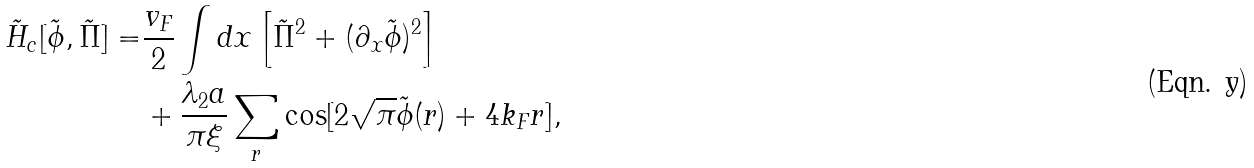Convert formula to latex. <formula><loc_0><loc_0><loc_500><loc_500>\tilde { H } _ { c } [ \tilde { \phi } , \tilde { \Pi } ] = & \frac { v _ { F } } { 2 } \int d x \left [ \tilde { \Pi } ^ { 2 } + ( \partial _ { x } \tilde { \phi } ) ^ { 2 } \right ] \\ & + \frac { \lambda _ { 2 } a } { \pi \xi } \sum _ { r } \cos [ 2 \sqrt { \pi } \tilde { \phi } ( r ) + 4 k _ { F } r ] ,</formula> 